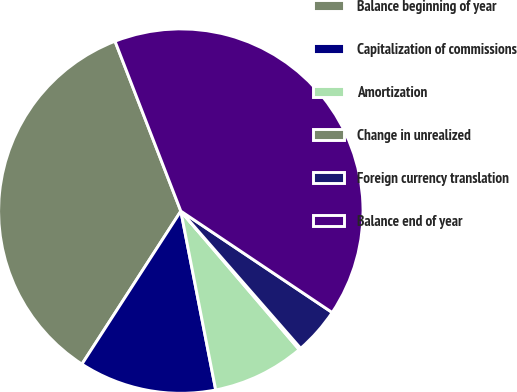Convert chart to OTSL. <chart><loc_0><loc_0><loc_500><loc_500><pie_chart><fcel>Balance beginning of year<fcel>Capitalization of commissions<fcel>Amortization<fcel>Change in unrealized<fcel>Foreign currency translation<fcel>Balance end of year<nl><fcel>34.99%<fcel>12.2%<fcel>8.19%<fcel>0.17%<fcel>4.18%<fcel>40.28%<nl></chart> 